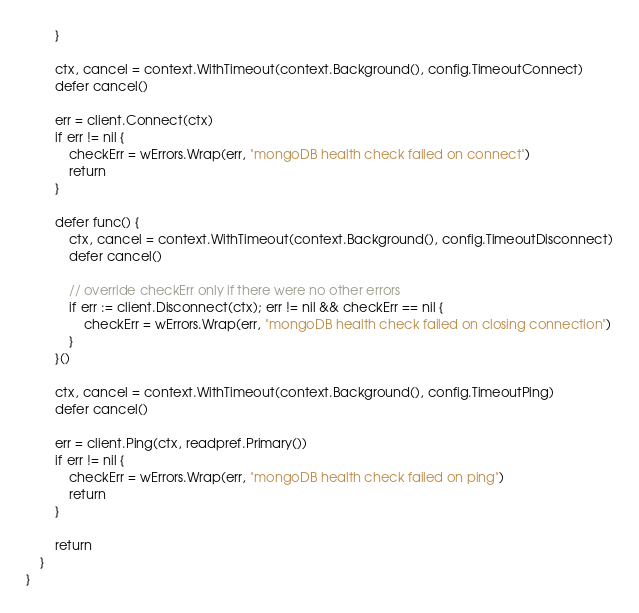<code> <loc_0><loc_0><loc_500><loc_500><_Go_>		}

		ctx, cancel = context.WithTimeout(context.Background(), config.TimeoutConnect)
		defer cancel()

		err = client.Connect(ctx)
		if err != nil {
			checkErr = wErrors.Wrap(err, "mongoDB health check failed on connect")
			return
		}

		defer func() {
			ctx, cancel = context.WithTimeout(context.Background(), config.TimeoutDisconnect)
			defer cancel()

			// override checkErr only if there were no other errors
			if err := client.Disconnect(ctx); err != nil && checkErr == nil {
				checkErr = wErrors.Wrap(err, "mongoDB health check failed on closing connection")
			}
		}()

		ctx, cancel = context.WithTimeout(context.Background(), config.TimeoutPing)
		defer cancel()

		err = client.Ping(ctx, readpref.Primary())
		if err != nil {
			checkErr = wErrors.Wrap(err, "mongoDB health check failed on ping")
			return
		}

		return
	}
}
</code> 